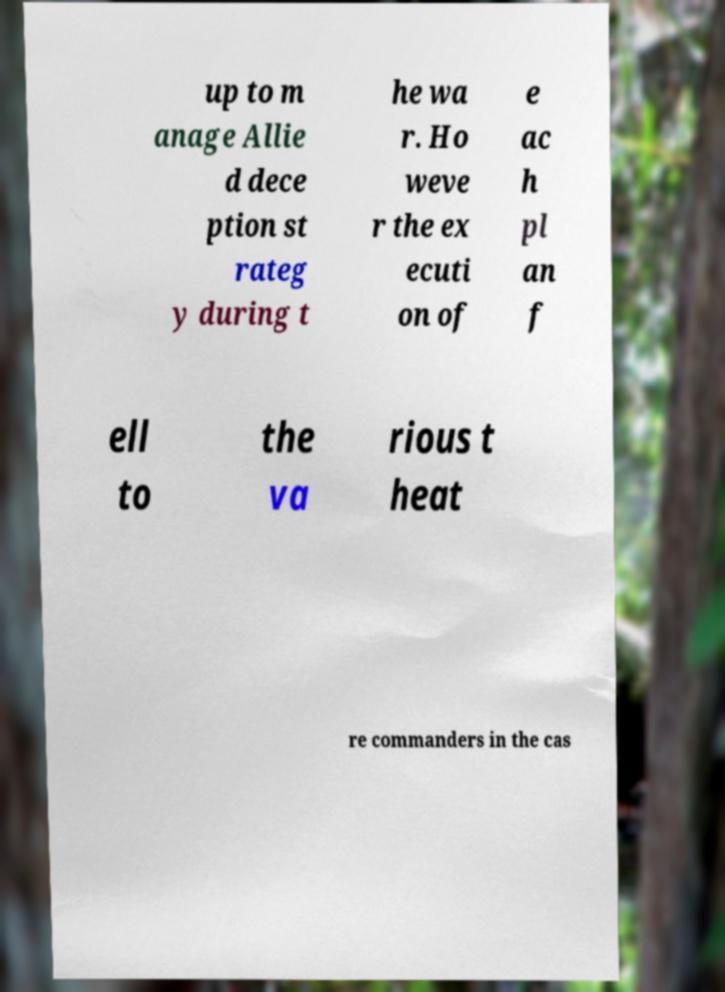Please read and relay the text visible in this image. What does it say? up to m anage Allie d dece ption st rateg y during t he wa r. Ho weve r the ex ecuti on of e ac h pl an f ell to the va rious t heat re commanders in the cas 